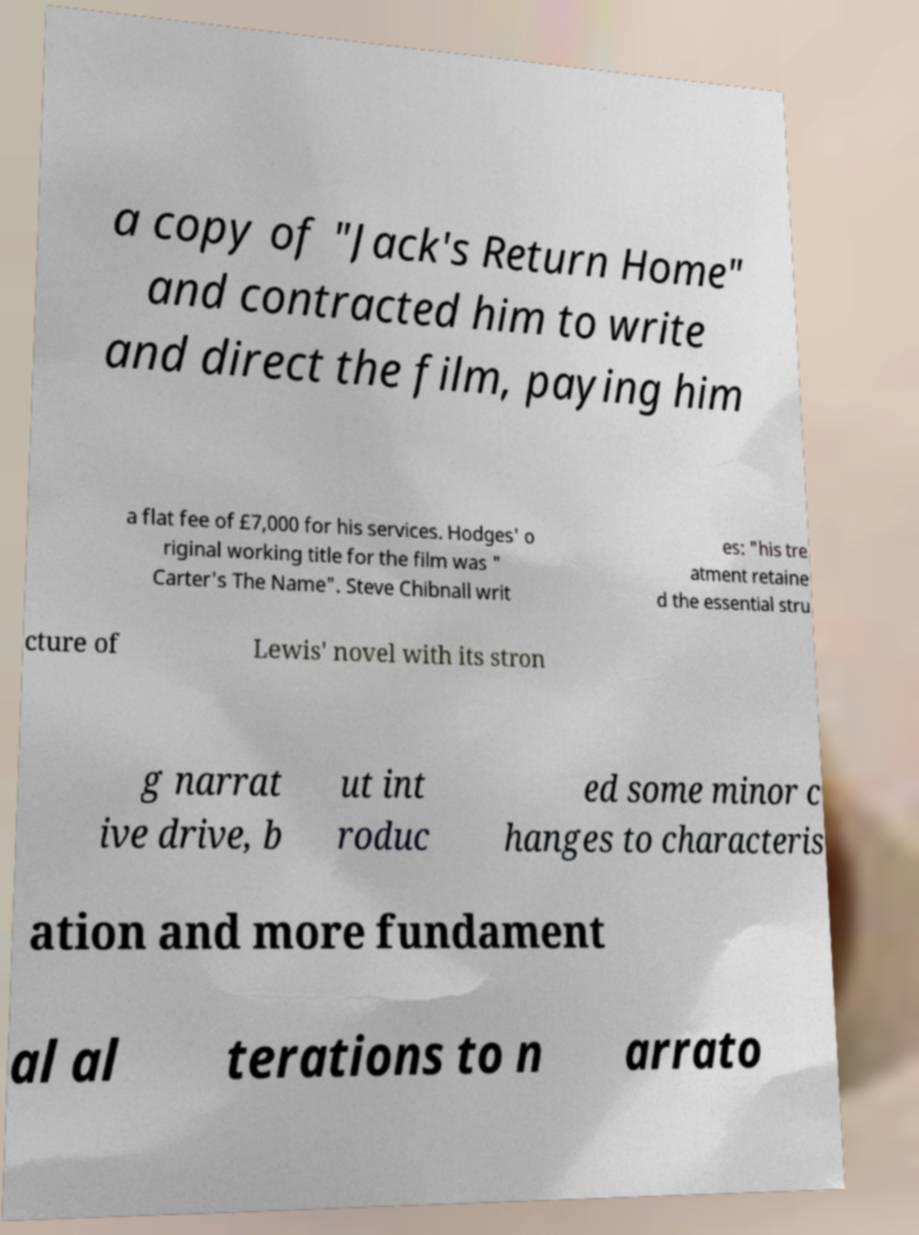Can you accurately transcribe the text from the provided image for me? a copy of "Jack's Return Home" and contracted him to write and direct the film, paying him a flat fee of £7,000 for his services. Hodges' o riginal working title for the film was " Carter's The Name". Steve Chibnall writ es: "his tre atment retaine d the essential stru cture of Lewis' novel with its stron g narrat ive drive, b ut int roduc ed some minor c hanges to characteris ation and more fundament al al terations to n arrato 